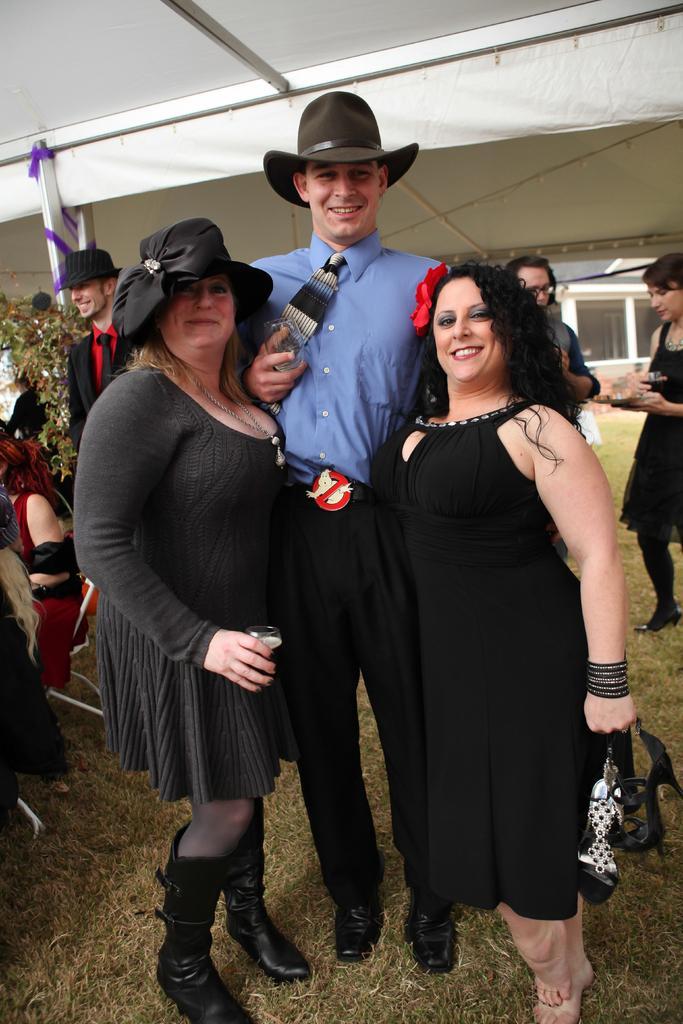Please provide a concise description of this image. In this picture we can see people standing on the grass and smiling at someone. Some people are wearing hats. In the background, we can see trees & windows. 